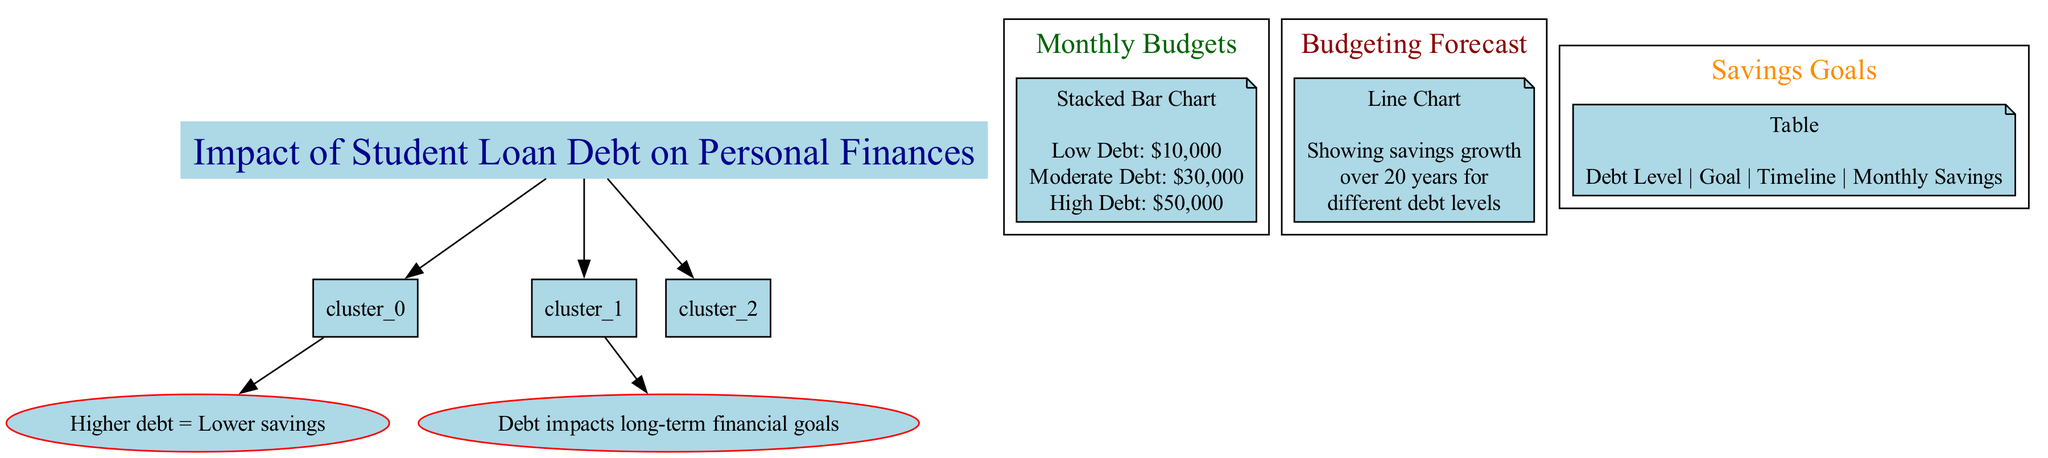What are the categories in the Monthly Budgets section? The diagram lists the categories as Rent, Utilities, Food, Transportation, Healthcare, Student Loan Payment, and Savings, clearly indicated in the Monthly Budgets section's stacked bar chart.
Answer: Rent, Utilities, Food, Transportation, Healthcare, Student Loan Payment, Savings How much is the monthly savings for individuals with High Debt? In the High Debt category in the Monthly Budgets section, the Savings value is $0, which directly indicates that individuals with high student loan debt are unable to allocate any portion of their budget towards savings.
Answer: $0 What is the total monthly budget for Moderate Debt? By adding up the values in the Moderate Debt section from the Monthly Budgets chart—800 (Rent) + 150 (Utilities) + 300 (Food) + 200 (Transportation) + 100 (Healthcare) + 300 (Student Loan Payment) + 100 (Savings)—the total comes to 1950 dollars.
Answer: $1950 What is the monthly savings required for the Emergency Fund goal with Low Debt? The Savings Goals table specifies that for the Low Debt level, the Monthly Savings Required to achieve an Emergency Fund in 2 Years is $100.
Answer: $100 What has been the savings growth in Year 10 for individuals with Low Debt? From the Budgeting Forecast line chart, the value for Low Debt in Year 10 is $500, showing the cumulative amount of savings at that time based on the projected growth.
Answer: $500 How does the monthly savings change between Moderate Debt and High Debt levels? By comparing the Monthly Budgets for Moderate Debt (Monthly Savings $100) and High Debt (Monthly Savings $0), we see that saving possibilities decrease significantly for individuals with High Debt, illustrating the impact of student loans on personal finances.
Answer: Decreases by $100 What is the savings goal timeline for the retirement fund under High Debt? According to the Savings Goals table, the goal for the High Debt category is to save for a Retirement Fund within a timeline of 10 Years.
Answer: 10 Years How many data points are shown in the Budgeting Forecast for High Debt? The Budgeting Forecast section contains data points for 5 different years (Year 1, Year 5, Year 10, Year 15, Year 20), making it easy to track the savings trend for individuals with High Debt.
Answer: 5 